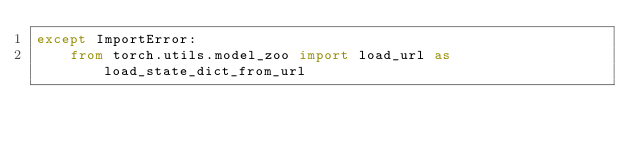<code> <loc_0><loc_0><loc_500><loc_500><_Python_>except ImportError:
    from torch.utils.model_zoo import load_url as load_state_dict_from_url
</code> 